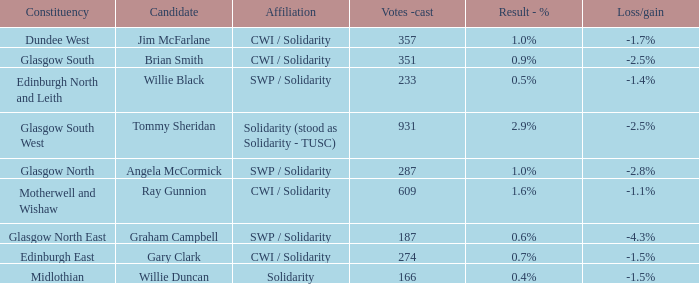Who as the candidate when the result - % was 2.9%? Tommy Sheridan. 